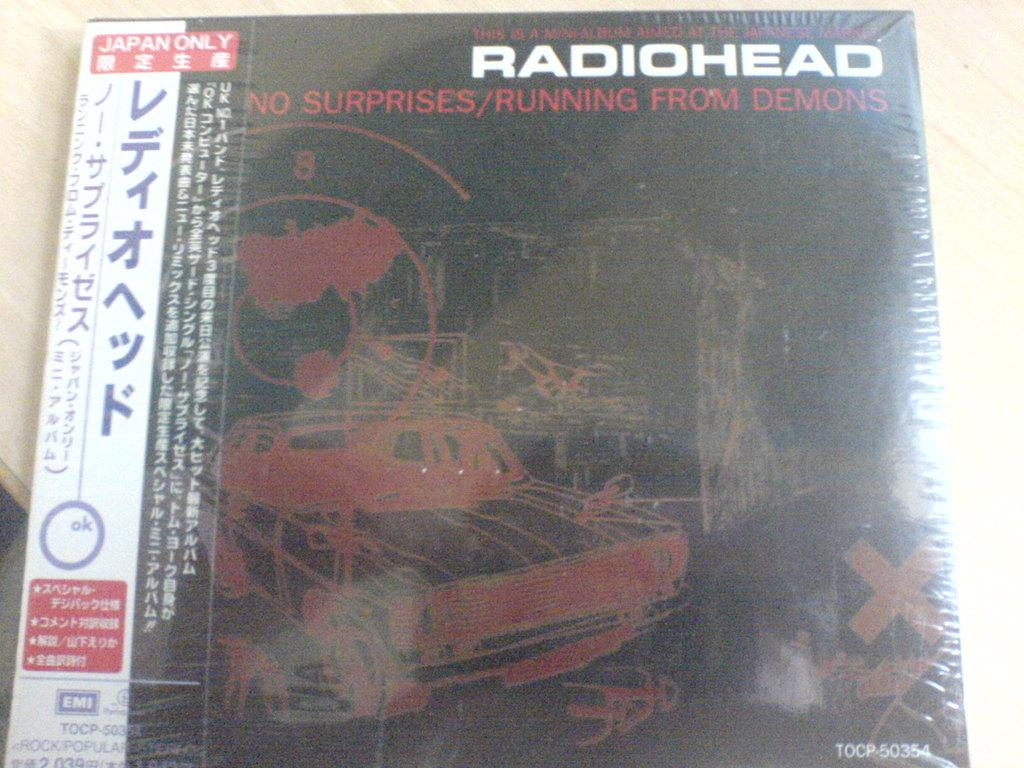<image>
Render a clear and concise summary of the photo. Japanese copy of a Radiohead record on vinyl. 